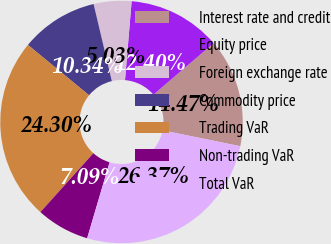<chart> <loc_0><loc_0><loc_500><loc_500><pie_chart><fcel>Interest rate and credit<fcel>Equity price<fcel>Foreign exchange rate<fcel>Commodity price<fcel>Trading VaR<fcel>Non-trading VaR<fcel>Total VaR<nl><fcel>14.47%<fcel>12.4%<fcel>5.03%<fcel>10.34%<fcel>24.3%<fcel>7.09%<fcel>26.37%<nl></chart> 